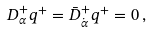Convert formula to latex. <formula><loc_0><loc_0><loc_500><loc_500>D ^ { + } _ { \alpha } q ^ { + } = \bar { D } ^ { + } _ { \dot { \alpha } } q ^ { + } = 0 \, ,</formula> 